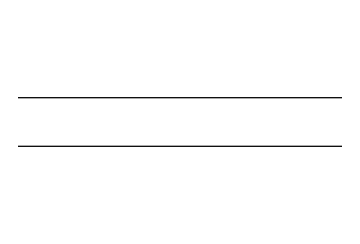What is the chemical formula for ethylene? The SMILES representation "C=C" indicates two carbon atoms bonded by a double bond. The chemical formula is derived from counting these atoms, resulting in C2H4.
Answer: C2H4 How many double bonds are present in this structure? The SMILES "C=C" indicates one double bond between the two carbon atoms, which is visually represented as C=C.
Answer: 1 What type of molecules does this gas belong to? Ethylene is classified as an alkene due to the presence of a carbon-carbon double bond (C=C) in its structure.
Answer: alkene Why is ethylene important for ripening? Ethylene acts as a plant hormone that regulates the ripening process by accelerating it, promoting changes in texture, color, and flavor of fruits.
Answer: plant hormone What is the state of ethylene at room temperature? Ethylene is a gas at room temperature, as indicated by its properties as an alkene and its widespread use in gas form for various applications.
Answer: gas Which elements make up ethylene? The SMILES "C=C" contains only carbon (C) and hydrogen (H) atoms, which are the elements constituting ethylene.
Answer: carbon, hydrogen How many hydrogen atoms are connected to each carbon in ethylene? In the structure represented by "C=C," each carbon atom is bonded to two hydrogen atoms, leading to a total of four hydrogen atoms connected to the two carbon atoms.
Answer: 2 